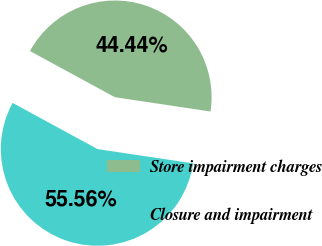<chart> <loc_0><loc_0><loc_500><loc_500><pie_chart><fcel>Store impairment charges<fcel>Closure and impairment<nl><fcel>44.44%<fcel>55.56%<nl></chart> 